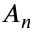Convert formula to latex. <formula><loc_0><loc_0><loc_500><loc_500>A _ { n }</formula> 